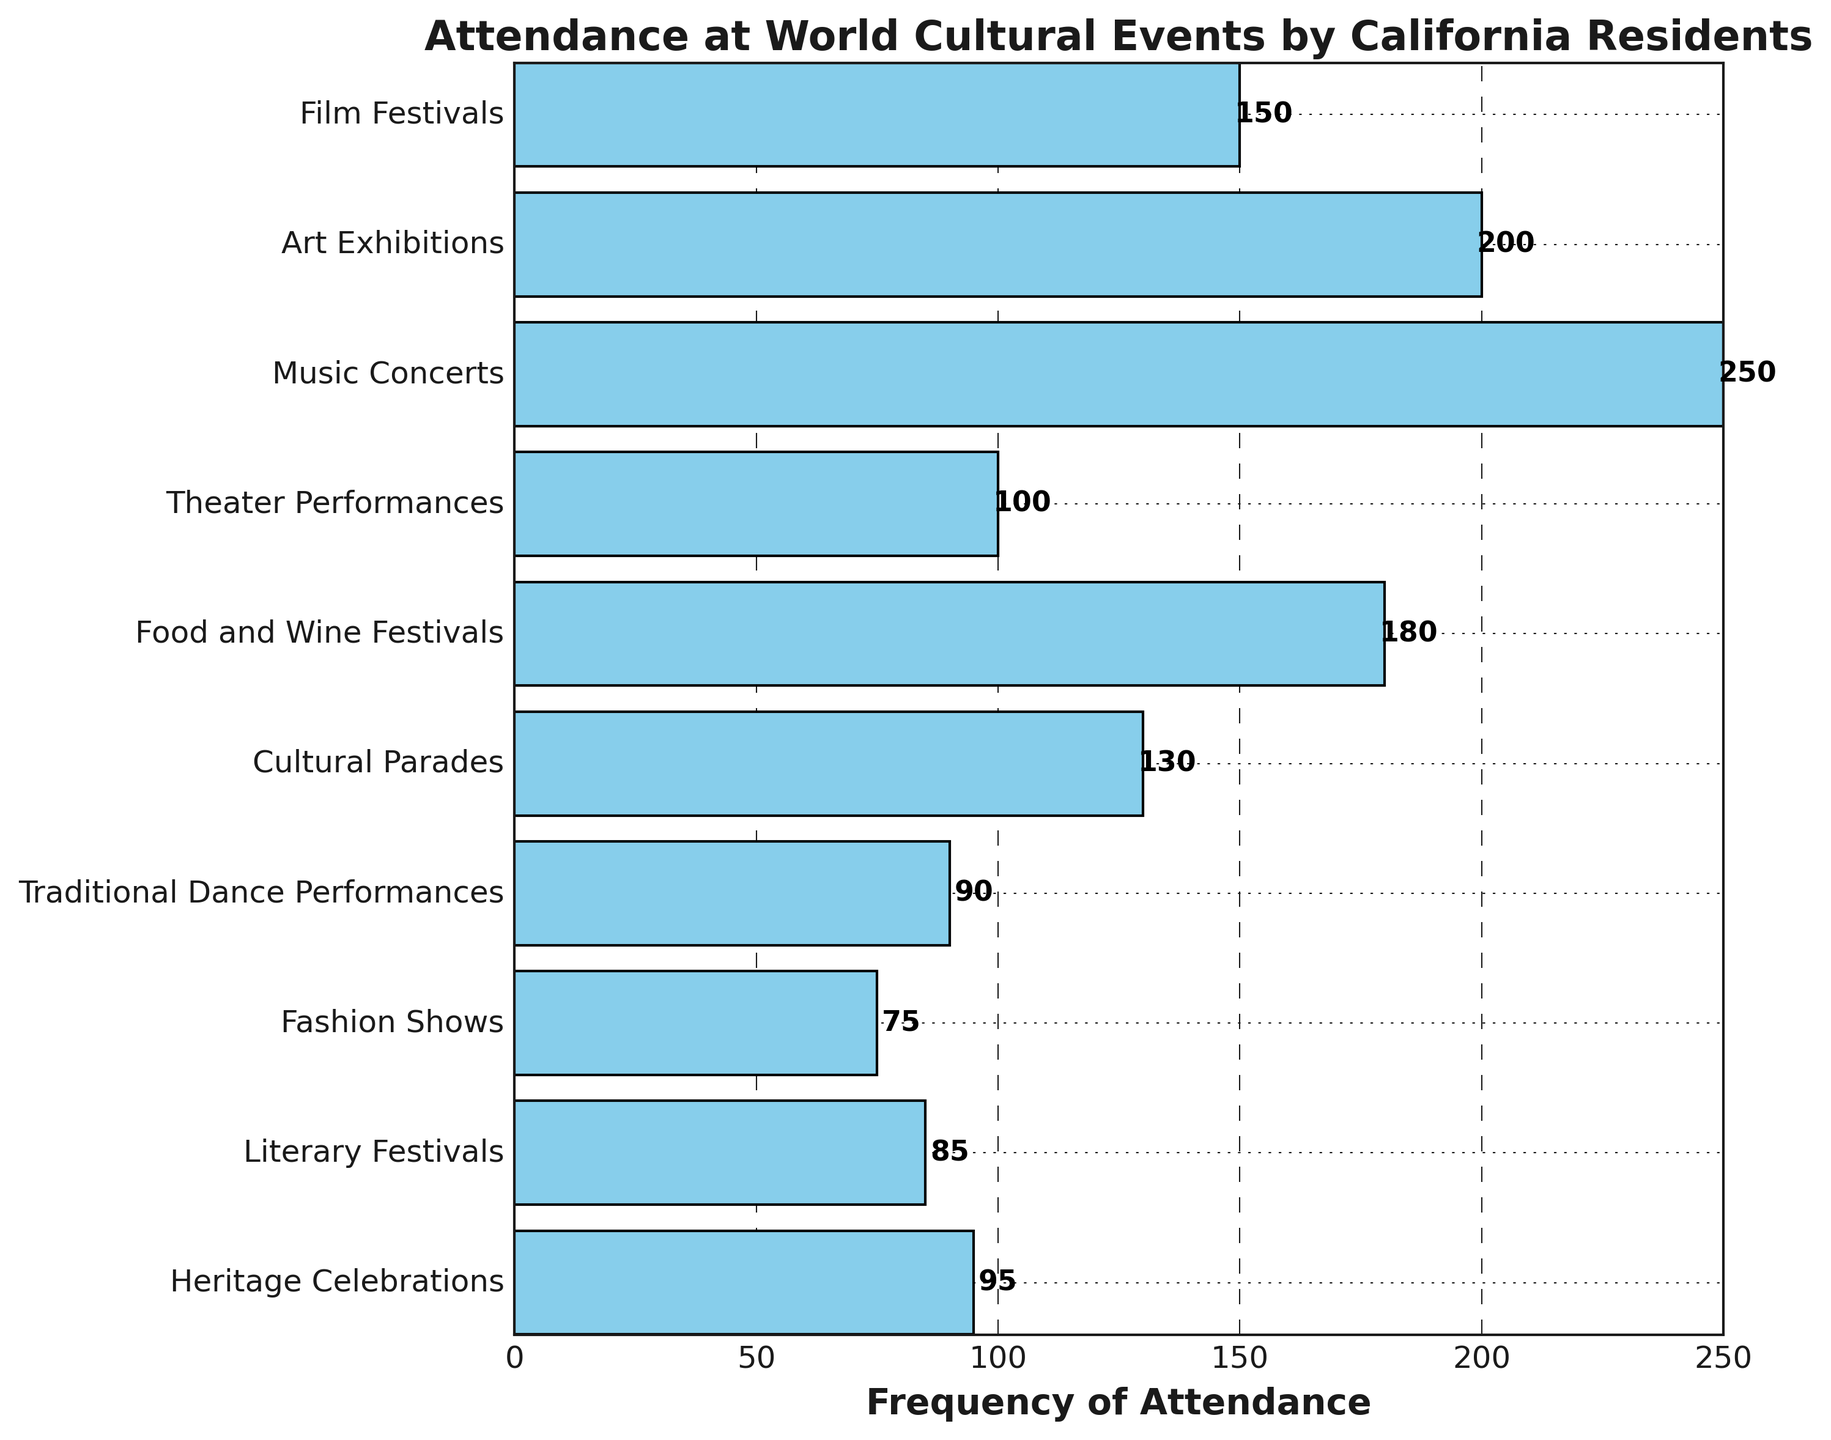What's the most frequently attended event? The bar with the longest length indicates the frequency of attendance. The music concerts bar is the longest, implying that it has the highest frequency of attendance.
Answer: Music Concerts Which event type has the lowest attendance? The bar with the shortest length is for fashion shows, therefore indicating the lowest frequency of attendance.
Answer: Fashion Shows How many events have an attendance frequency higher than 150? To determine this, count the bars with frequencies greater than 150. These are art exhibitions, music concerts, and food and wine festivals. Thus, there are 3 such events.
Answer: 3 What is the combined frequency of attendance for film festivals and food and wine festivals? Sum the frequencies of both events: Film Festivals (150) + Food and Wine Festivals (180) = 330.
Answer: 330 Is the attendance for literary festivals higher or lower than traditional dance performances? Compare the lengths of the bars for both events. Literary festivals have an attendance of 85, which is lower than traditional dance performances at 90.
Answer: Lower By how much does the attendance for cultural parades exceed heritage celebrations? Calculate the difference between the two frequencies: Cultural Parades (130) - Heritage Celebrations (95) = 35.
Answer: 35 Which event type has approximately half the attendance frequency of music concerts? Calculate half of the frequency of music concerts: 250 / 2 = 125. Cultural parades, with an attendance of 130, are close enough to this value.
Answer: Cultural Parades What is the average attendance frequency of the top three most attended events? Identify the top three: music concerts (250), art exhibitions (200), and food and wine festivals (180). Compute the average: (250 + 200 + 180) / 3 = 210.
Answer: 210 Which two event types have the closest attendance frequencies? Examine the bars to find the closest values in length. Heritage celebrations (95) and traditional dance performances (90) have the closest attendance frequencies.
Answer: Heritage Celebrations and Traditional Dance Performances What is the total frequency of attendance for all the events? Sum the frequencies of all event types: 150 + 200 + 250 + 100 + 180 + 130 + 90 + 75 + 85 + 95 = 1355.
Answer: 1355 